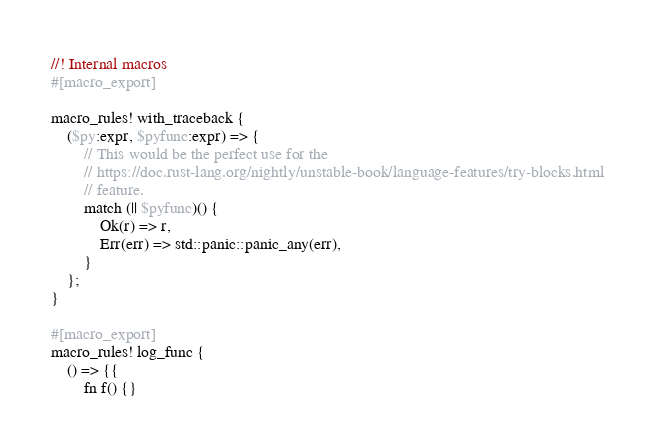Convert code to text. <code><loc_0><loc_0><loc_500><loc_500><_Rust_>//! Internal macros
#[macro_export]

macro_rules! with_traceback {
    ($py:expr, $pyfunc:expr) => {
        // This would be the perfect use for the
        // https://doc.rust-lang.org/nightly/unstable-book/language-features/try-blocks.html
        // feature.
        match (|| $pyfunc)() {
            Ok(r) => r,
            Err(err) => std::panic::panic_any(err),
        }
    };
}

#[macro_export]
macro_rules! log_func {
    () => {{
        fn f() {}</code> 